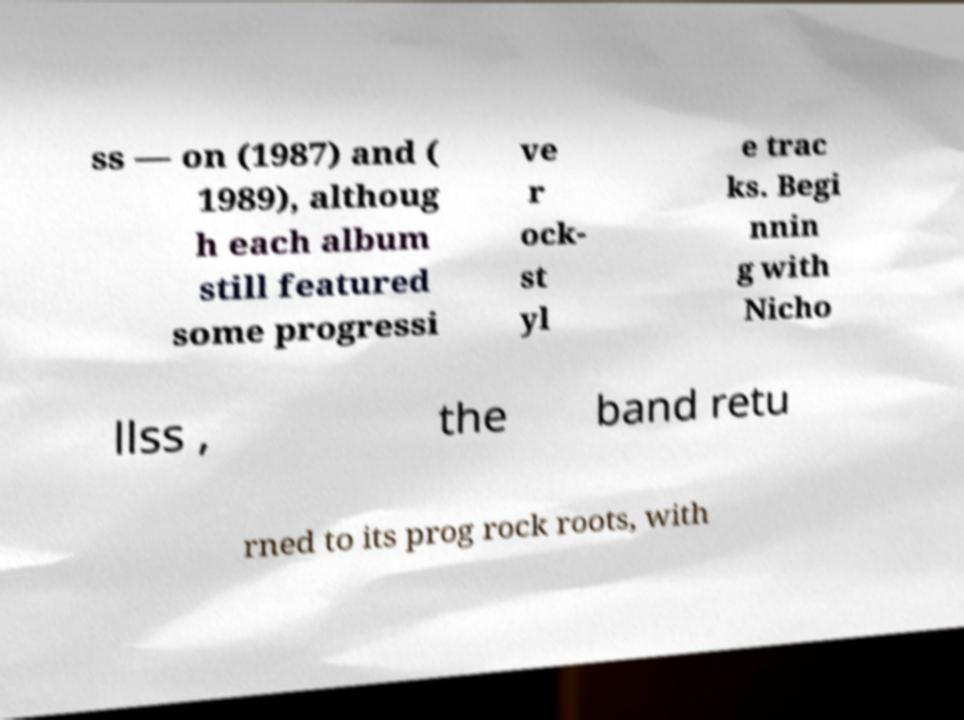Could you extract and type out the text from this image? ss — on (1987) and ( 1989), althoug h each album still featured some progressi ve r ock- st yl e trac ks. Begi nnin g with Nicho llss , the band retu rned to its prog rock roots, with 